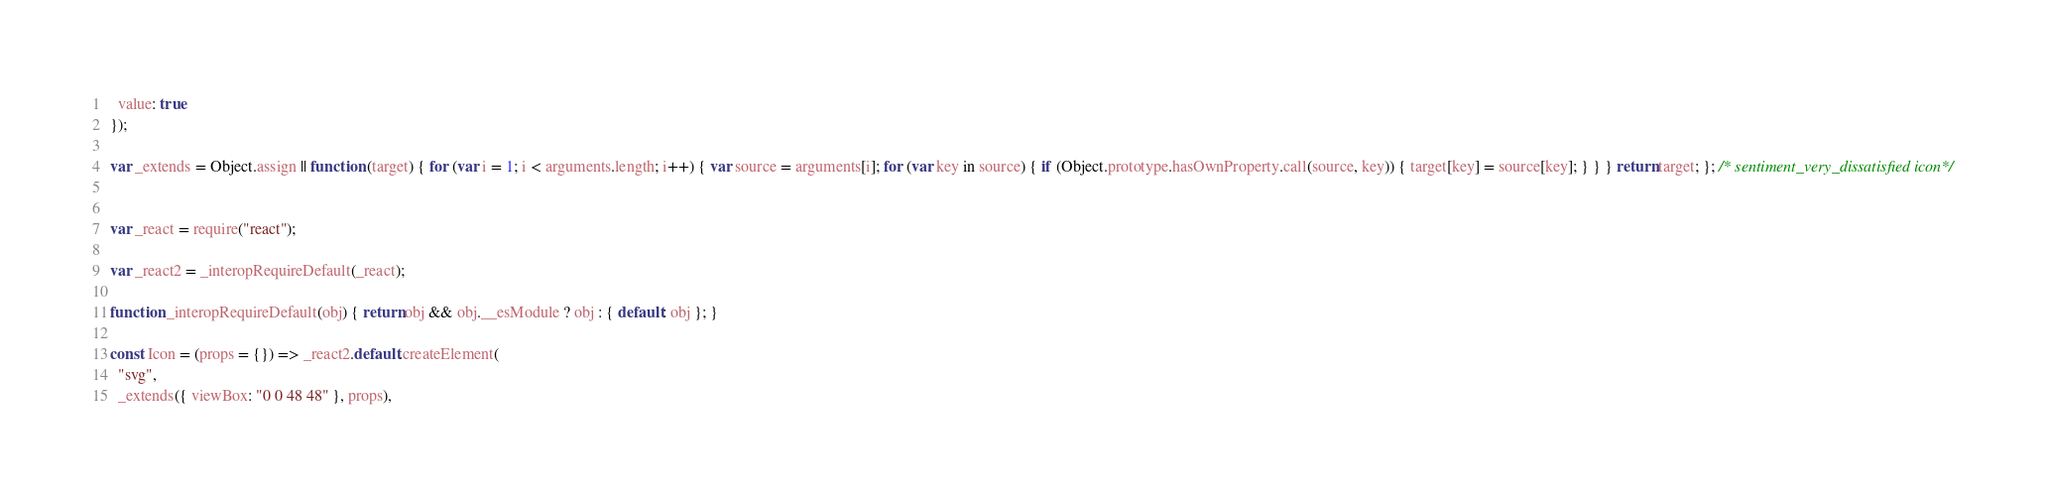<code> <loc_0><loc_0><loc_500><loc_500><_JavaScript_>  value: true
});

var _extends = Object.assign || function (target) { for (var i = 1; i < arguments.length; i++) { var source = arguments[i]; for (var key in source) { if (Object.prototype.hasOwnProperty.call(source, key)) { target[key] = source[key]; } } } return target; }; /* sentiment_very_dissatisfied icon*/


var _react = require("react");

var _react2 = _interopRequireDefault(_react);

function _interopRequireDefault(obj) { return obj && obj.__esModule ? obj : { default: obj }; }

const Icon = (props = {}) => _react2.default.createElement(
  "svg",
  _extends({ viewBox: "0 0 48 48" }, props),</code> 